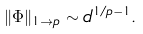<formula> <loc_0><loc_0><loc_500><loc_500>\| \Phi \| _ { 1 \to p } \sim d ^ { 1 / p - 1 } .</formula> 